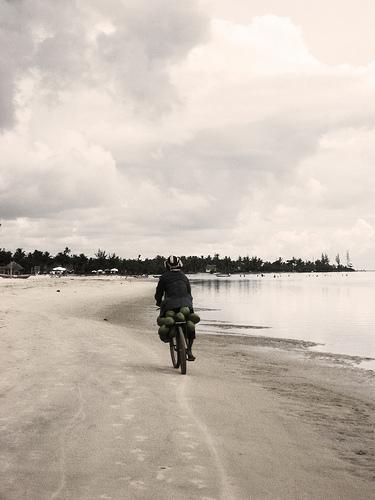How many people are on the bike?
Give a very brief answer. 1. 